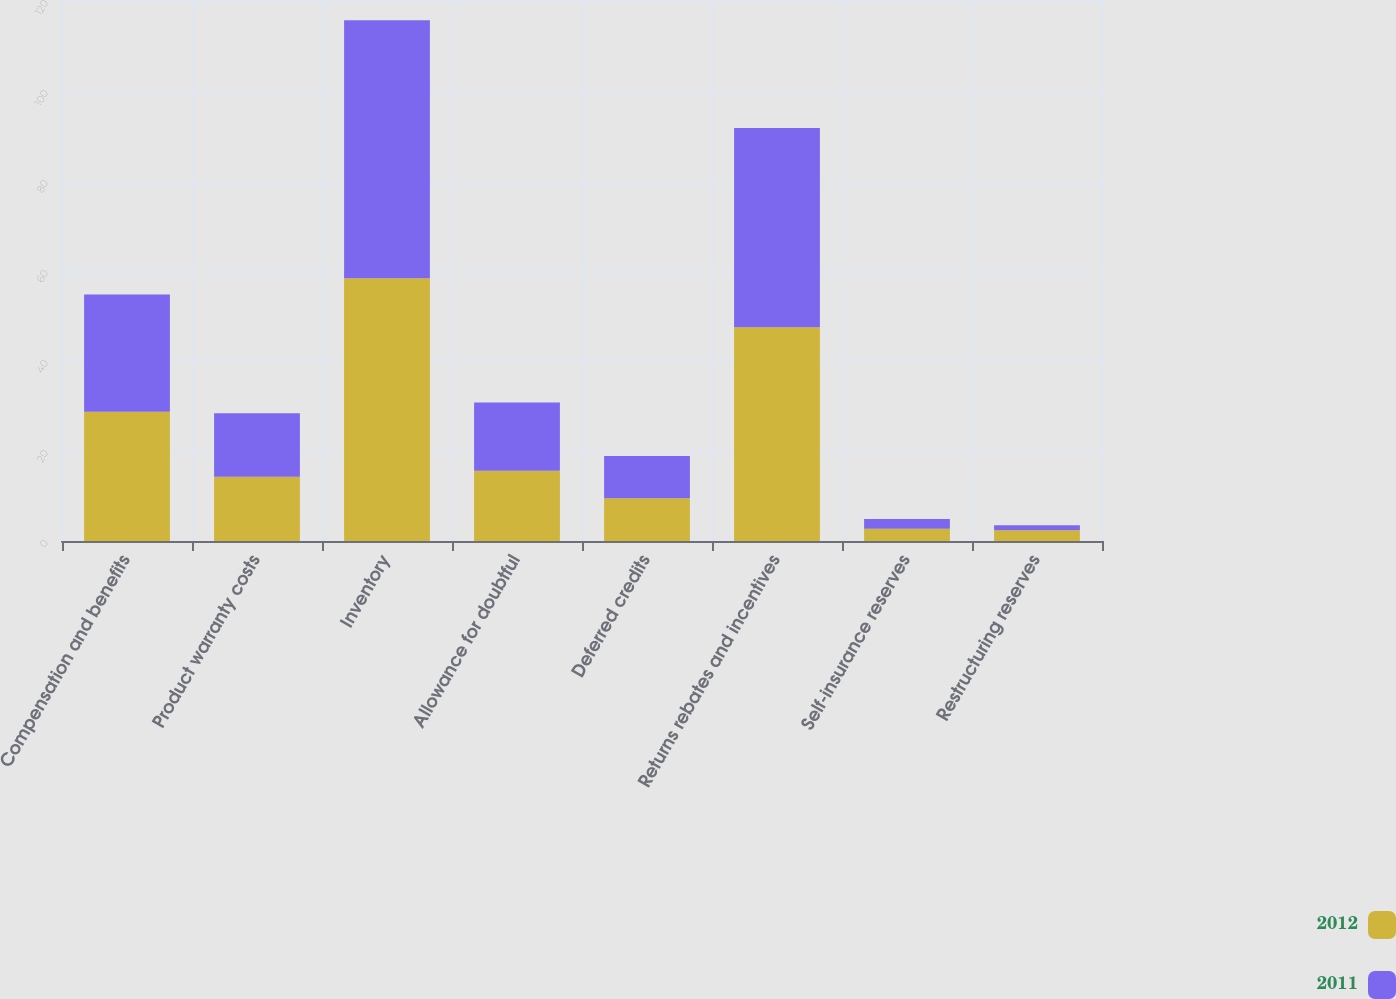Convert chart. <chart><loc_0><loc_0><loc_500><loc_500><stacked_bar_chart><ecel><fcel>Compensation and benefits<fcel>Product warranty costs<fcel>Inventory<fcel>Allowance for doubtful<fcel>Deferred credits<fcel>Returns rebates and incentives<fcel>Self-insurance reserves<fcel>Restructuring reserves<nl><fcel>2012<fcel>28.7<fcel>14.3<fcel>58.4<fcel>15.6<fcel>9.5<fcel>47.5<fcel>2.7<fcel>2.4<nl><fcel>2011<fcel>26.1<fcel>14.1<fcel>57.3<fcel>15.2<fcel>9.4<fcel>44.3<fcel>2.2<fcel>1.1<nl></chart> 